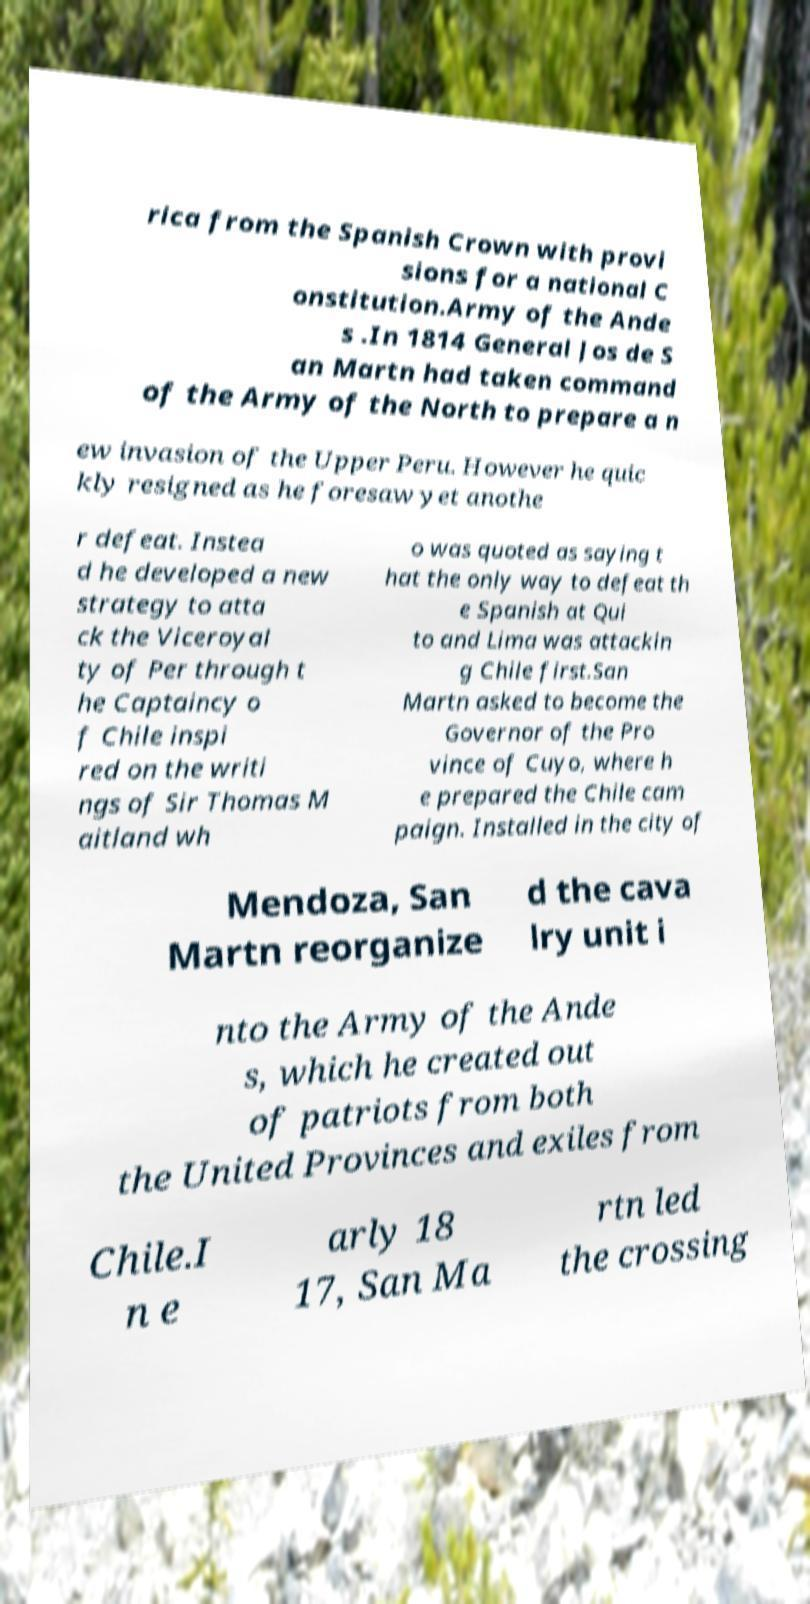Could you assist in decoding the text presented in this image and type it out clearly? rica from the Spanish Crown with provi sions for a national C onstitution.Army of the Ande s .In 1814 General Jos de S an Martn had taken command of the Army of the North to prepare a n ew invasion of the Upper Peru. However he quic kly resigned as he foresaw yet anothe r defeat. Instea d he developed a new strategy to atta ck the Viceroyal ty of Per through t he Captaincy o f Chile inspi red on the writi ngs of Sir Thomas M aitland wh o was quoted as saying t hat the only way to defeat th e Spanish at Qui to and Lima was attackin g Chile first.San Martn asked to become the Governor of the Pro vince of Cuyo, where h e prepared the Chile cam paign. Installed in the city of Mendoza, San Martn reorganize d the cava lry unit i nto the Army of the Ande s, which he created out of patriots from both the United Provinces and exiles from Chile.I n e arly 18 17, San Ma rtn led the crossing 